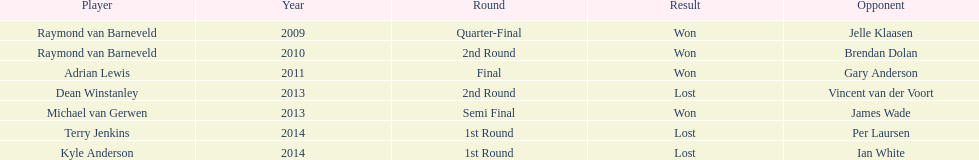Other than kyle anderson, who else lost in 2014? Terry Jenkins. 